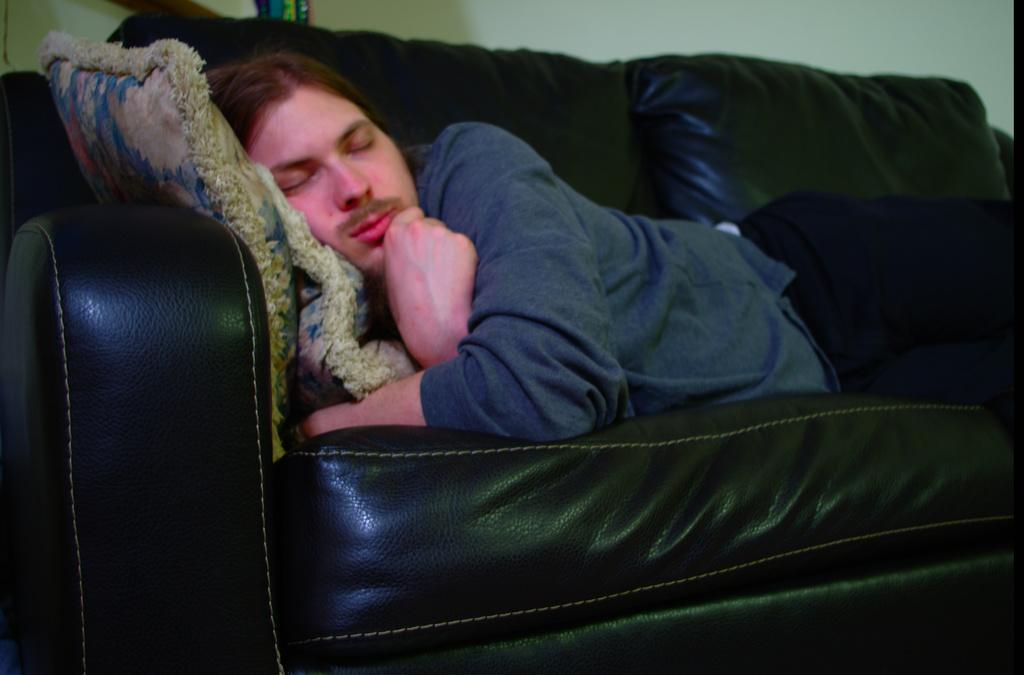Who is present in the image? There is a man in the image. What is the man doing in the image? The man is lying on a sofa. What can be seen on the sofa besides the man? There are cushions on the sofa. What type of mitten is the man wearing in the image? The man is not wearing a mitten in the image; he is lying on a sofa with cushions. What is the man thinking about while lying on the sofa? The image does not provide any information about the man's thoughts or what he might be thinking about. 